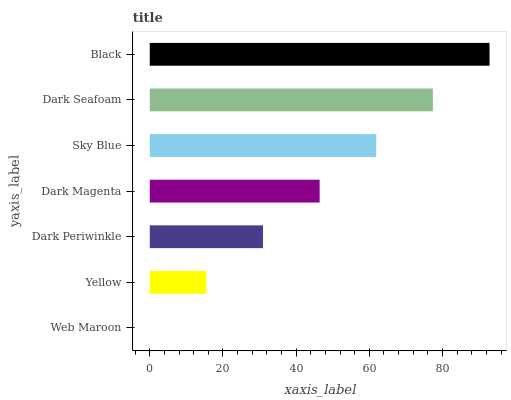Is Web Maroon the minimum?
Answer yes or no. Yes. Is Black the maximum?
Answer yes or no. Yes. Is Yellow the minimum?
Answer yes or no. No. Is Yellow the maximum?
Answer yes or no. No. Is Yellow greater than Web Maroon?
Answer yes or no. Yes. Is Web Maroon less than Yellow?
Answer yes or no. Yes. Is Web Maroon greater than Yellow?
Answer yes or no. No. Is Yellow less than Web Maroon?
Answer yes or no. No. Is Dark Magenta the high median?
Answer yes or no. Yes. Is Dark Magenta the low median?
Answer yes or no. Yes. Is Dark Seafoam the high median?
Answer yes or no. No. Is Dark Periwinkle the low median?
Answer yes or no. No. 